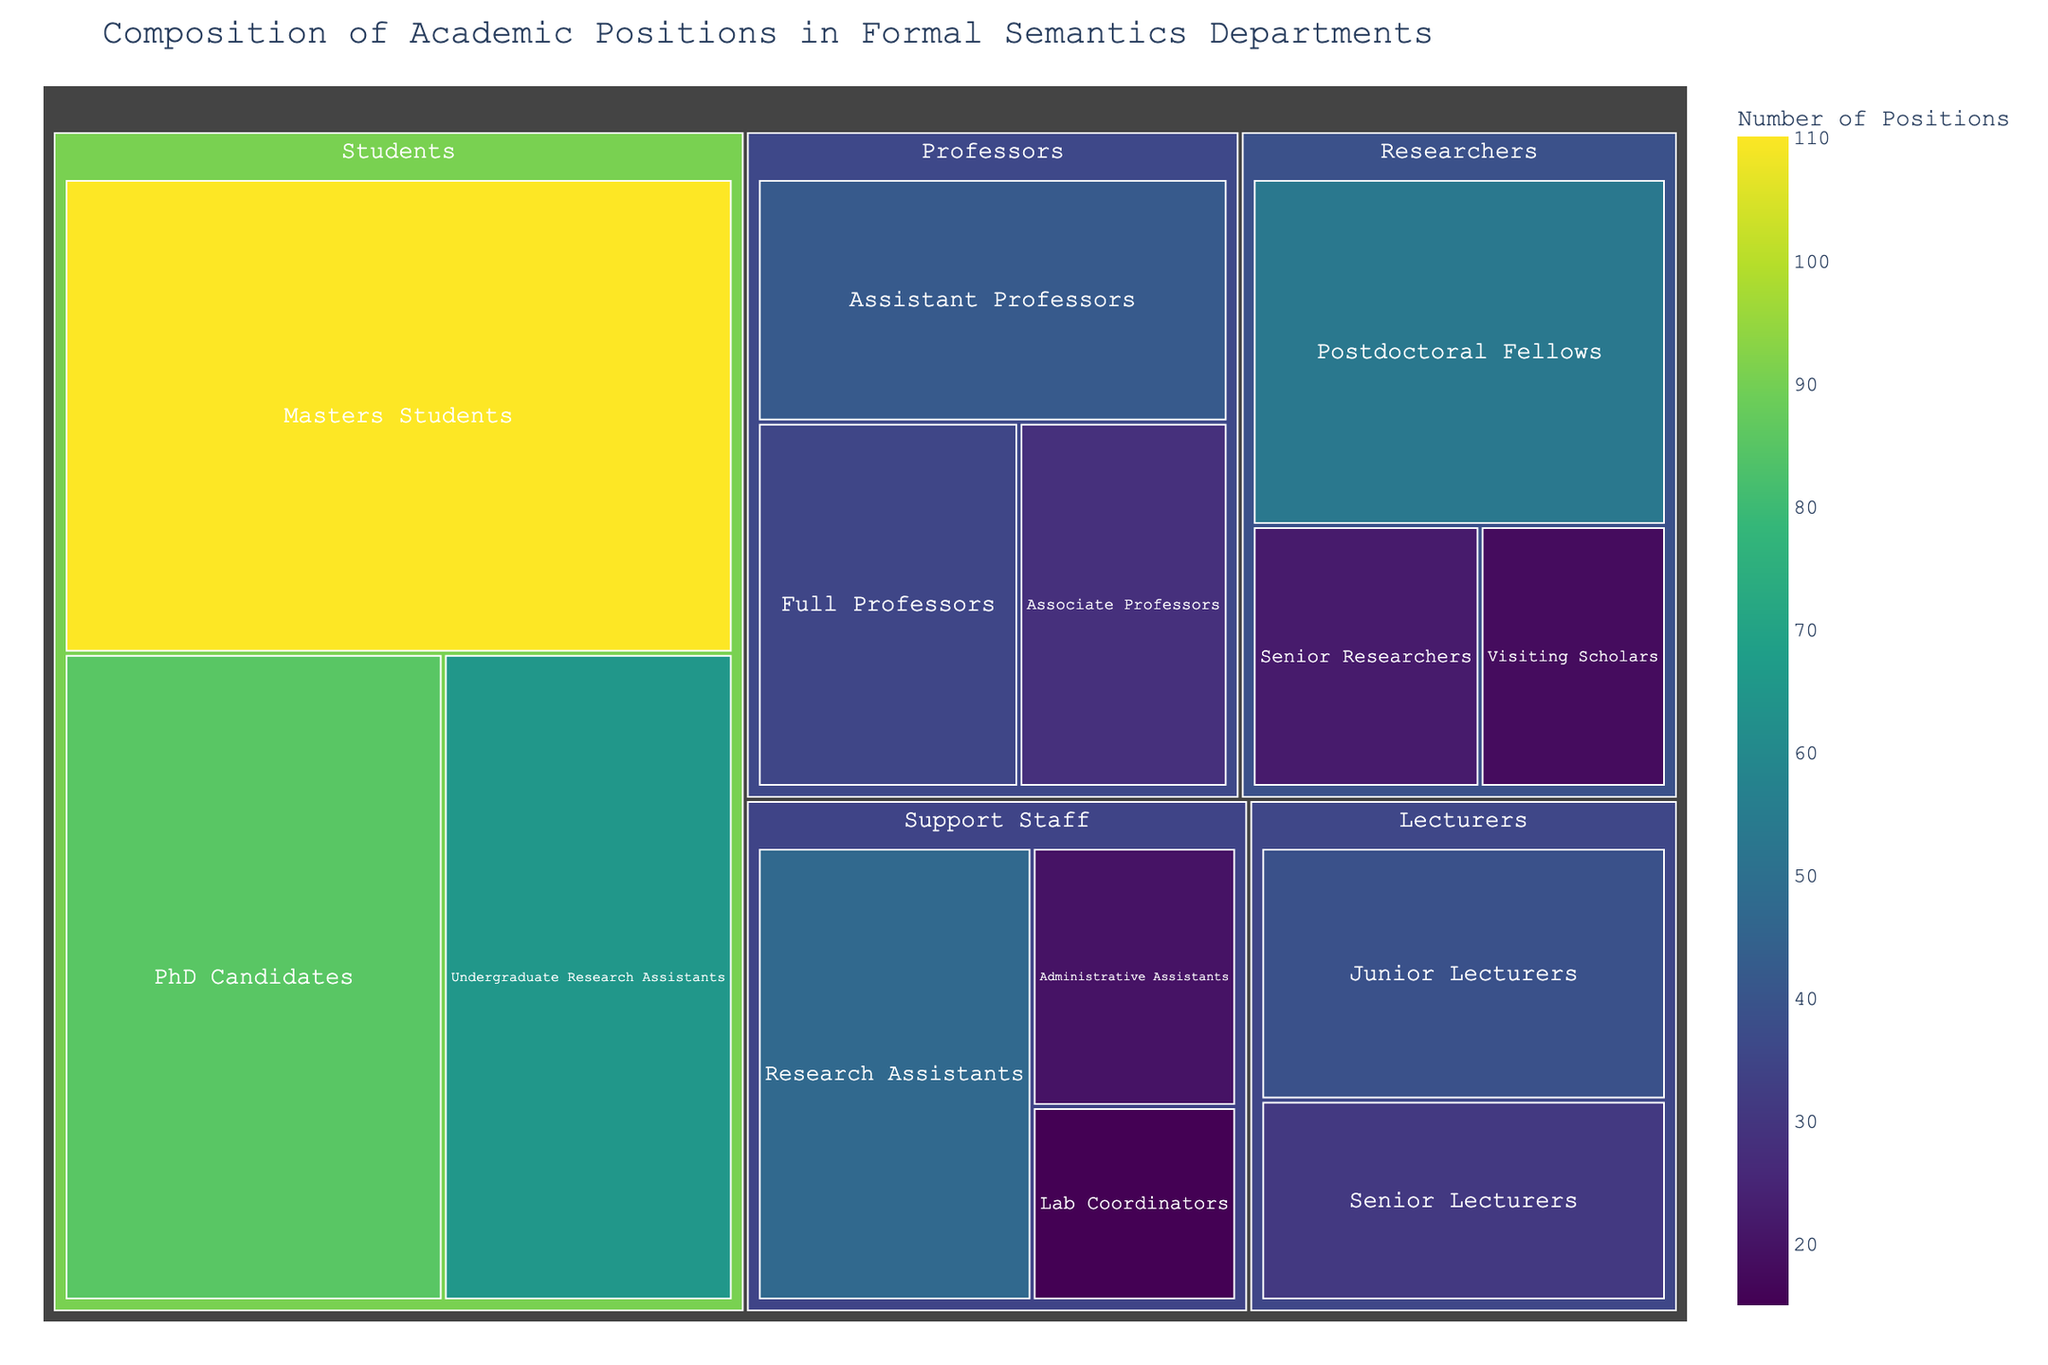What is the title of the figure? The title is typically displayed at the top of the figure. In this case, it is "Composition of Academic Positions in Formal Semantics Departments" as the code specifies it.
Answer: Composition of Academic Positions in Formal Semantics Departments Which subcategory has the highest number of positions? The treemap uses size to represent the number of positions. The largest block will represent the subcategory with the highest number of positions. According to the data, "Masters Students" has the highest value, 110.
Answer: Masters Students How many student positions are shown in the figure? Sum the values for the subcategories under Students: PhD Candidates (85) + Masters Students (110) + Undergraduate Research Assistants (65). 85 + 110 + 65 = 260.
Answer: 260 Which has more positions: Junior Lecturers or Senior Researchers? Compare the values for these two subcategories. Junior Lecturers have 39 positions, while Senior Researchers have 22 positions. Hence, Junior Lecturers have more positions.
Answer: Junior Lecturers What is the total number of professor positions? Sum the values for the subcategories under Professors: Full Professors (35) + Associate Professors (28) + Assistant Professors (42). 35 + 28 + 42 = 105.
Answer: 105 Which category has the fewest total positions? Calculate the total for each category and compare. Support Staff: 15 + 47 + 20 = 82; Lecturers: 31 + 39 = 70; Researchers: 22 + 53 + 18 = 93; Students: 85 + 110 + 65 = 260; Professors: 35 + 28 + 42 = 105. The category with the lowest total is Lecturers with 70 positions.
Answer: Lecturers What is the position count for Research Assistants in the figure? Identify the block labeled "Research Assistants" within the Support Staff category. The value is 47.
Answer: 47 Compare the number of postdoctoral fellows to the total number of assistant professors and senior lecturers combined. Which has more? There are 53 Postdoctoral Fellows. The sum of Assistant Professors and Senior Lecturers is 42 + 31 = 73. Since 73 > 53, the combined total of Assistant Professors and Senior Lecturers is higher.
Answer: Assistant Professors and Senior Lecturers combined What is the most common color used for categories with the highest numbers of positions? The color mapping represents the value, with Viridis being the color scale used. "Masters Students" is the subcategory with the highest number of positions, and it will be represented in the color corresponding to the highest end of the Viridis scale, which is usually bright yellow-green.
Answer: Bright yellow-green What is the total number of positions in the Researchers category? Sum the values for the subcategories under Researchers: Senior Researchers (22) + Postdoctoral Fellows (53) + Visiting Scholars (18). 22 + 53 + 18 = 93.
Answer: 93 